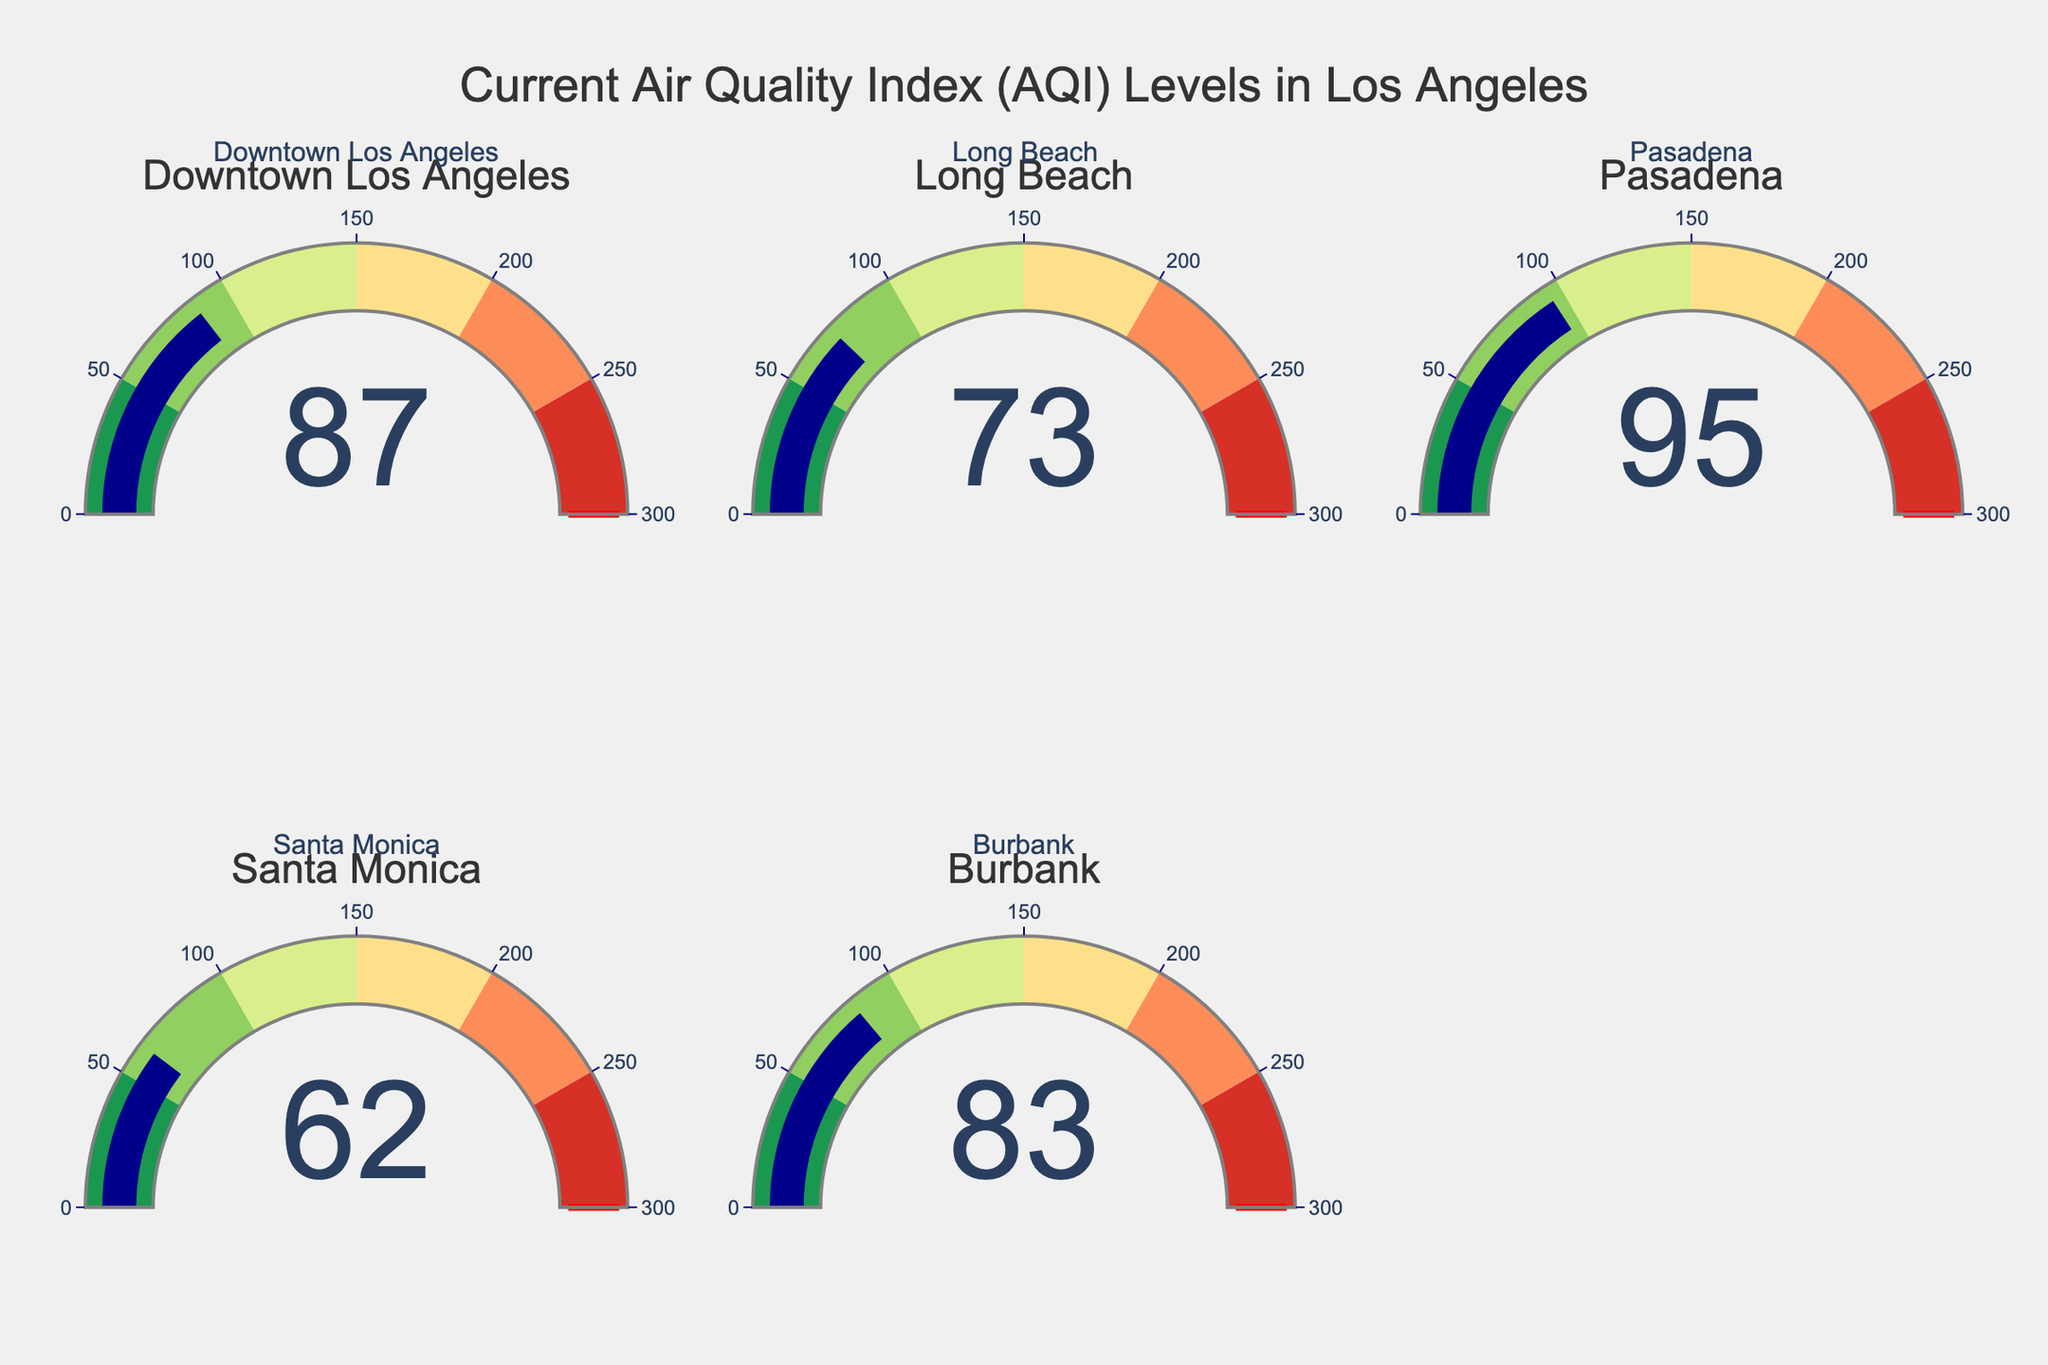What is the AQI level in Downtown Los Angeles? The AQI level for each location is displayed in the gauge indicators. For Downtown Los Angeles, the gauge shows an AQI of 87.
Answer: 87 Which location has the highest AQI level? By comparing the AQI values on each gauge, we can see that Pasadena has the highest AQI level with a value of 95.
Answer: Pasadena Which location has the lowest AQI level? By inspecting the AQI values on each gauge, Santa Monica has the lowest AQI level with a value of 62.
Answer: Santa Monica What is the average AQI level for all the locations? The AQI levels for all locations are 87, 73, 95, 62, and 83. Summing these values: 87 + 73 + 95 + 62 + 83 = 400. The number of locations is 5. Therefore, the average AQI level is 400 / 5 = 80.
Answer: 80 Which locations have an AQI level below 80? The locations and their AQI levels are Downtown Los Angeles (87), Long Beach (73), Pasadena (95), Santa Monica (62), and Burbank (83). Both Long Beach and Santa Monica have AQI levels below 80.
Answer: Long Beach and Santa Monica How many locations have an AQI level greater than 80? From the AQI values provided: Downtown Los Angeles (87), Long Beach (73), Pasadena (95), Santa Monica (62), and Burbank (83), we can see that three locations have AQI levels greater than 80: Downtown Los Angeles, Pasadena, and Burbank.
Answer: 3 What is the difference in AQI levels between Pasadena and Santa Monica? The AQI level for Pasadena is 95 and for Santa Monica is 62. The difference is 95 - 62 = 33.
Answer: 33 Ordering the locations from the lowest to highest AQI level, what would be the sequence? The AQI levels are: Downtown Los Angeles (87), Long Beach (73), Pasadena (95), Santa Monica (62), and Burbank (83). Ordering these from lowest to highest: Santa Monica (62), Long Beach (73), Burbank (83), Downtown Los Angeles (87), Pasadena (95).
Answer: Santa Monica, Long Beach, Burbank, Downtown Los Angeles, Pasadena Which locations fall in the "Moderate" AQI category (51-100)? The "Moderate" AQI category ranges from 51-100. The locations and their AQI levels are Downtown Los Angeles (87), Long Beach (73), Pasadena (95), Santa Monica (62), and Burbank (83). All five locations fall within this range.
Answer: Downtown Los Angeles, Long Beach, Pasadena, Santa Monica, Burbank What is the AQI level range covered by the gauge indicators? The gauge indicators show AQI levels ranging from 0 to 300.
Answer: 0-300 